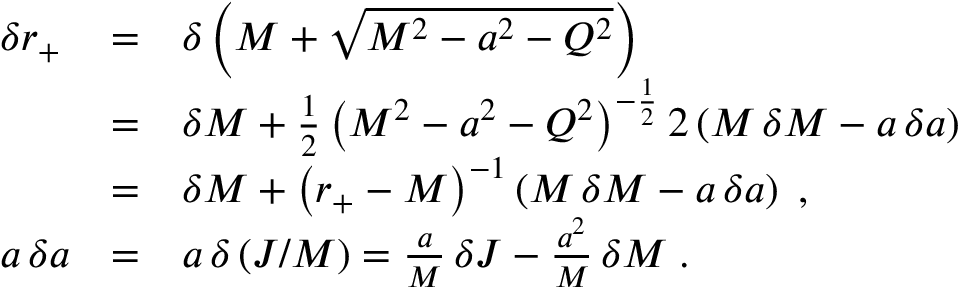Convert formula to latex. <formula><loc_0><loc_0><loc_500><loc_500>\begin{array} { l l l } { { \delta r _ { + } } } & { = } & { { \delta \left ( M + \sqrt { M ^ { 2 } - a ^ { 2 } - Q ^ { 2 } } \right ) } } & { = } & { { \delta M + { \frac { 1 } { 2 } } \, { \left ( M ^ { 2 } - a ^ { 2 } - Q ^ { 2 } \right ) } ^ { - { \frac { 1 } { 2 } } } \, 2 \left ( M \, \delta M - a \, \delta a \right ) } } & { = } & { { \delta M + { \left ( r _ { + } - M \right ) } ^ { - 1 } \left ( M \, \delta M - a \, \delta a \right ) \, , } } \\ { a \, \delta a } & { = } & { { a \, \delta \left ( J / M \right ) = { \frac { a } { M } } \, \delta J - { \frac { a ^ { 2 } } { M } } \, \delta M \, . } } \end{array}</formula> 